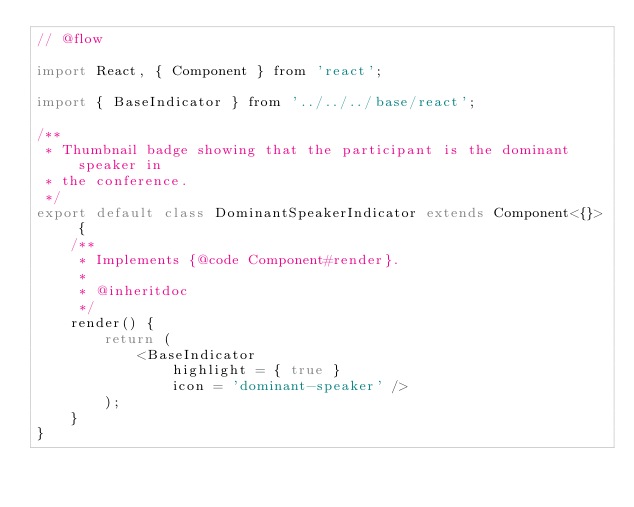<code> <loc_0><loc_0><loc_500><loc_500><_JavaScript_>// @flow

import React, { Component } from 'react';

import { BaseIndicator } from '../../../base/react';

/**
 * Thumbnail badge showing that the participant is the dominant speaker in
 * the conference.
 */
export default class DominantSpeakerIndicator extends Component<{}> {
    /**
     * Implements {@code Component#render}.
     *
     * @inheritdoc
     */
    render() {
        return (
            <BaseIndicator
                highlight = { true }
                icon = 'dominant-speaker' />
        );
    }
}
</code> 